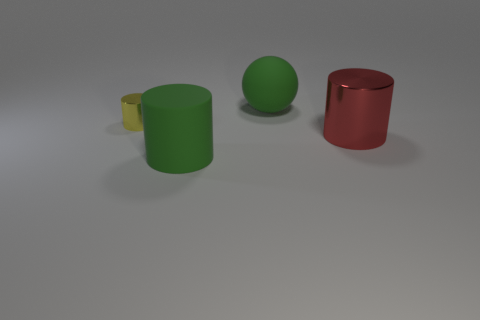There is a red object that is the same material as the tiny yellow cylinder; what shape is it?
Provide a succinct answer. Cylinder. There is a cylinder behind the red object; what material is it?
Your answer should be very brief. Metal. Is the color of the large thing that is on the left side of the green sphere the same as the rubber sphere?
Your answer should be very brief. Yes. How big is the thing to the left of the green object that is in front of the big green sphere?
Your answer should be compact. Small. Are there more cylinders left of the rubber cylinder than small yellow metallic cubes?
Provide a succinct answer. Yes. There is a matte object left of the green matte sphere; does it have the same size as the sphere?
Your answer should be very brief. Yes. What is the color of the large object that is in front of the tiny cylinder and on the right side of the green cylinder?
Provide a short and direct response. Red. What is the shape of the rubber thing that is the same size as the rubber cylinder?
Provide a short and direct response. Sphere. Is there a cylinder that has the same color as the sphere?
Offer a terse response. Yes. Are there an equal number of tiny yellow things in front of the green cylinder and large brown rubber cylinders?
Offer a terse response. Yes. 